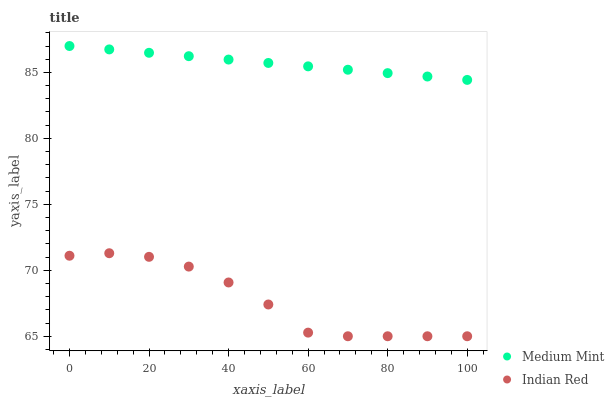Does Indian Red have the minimum area under the curve?
Answer yes or no. Yes. Does Medium Mint have the maximum area under the curve?
Answer yes or no. Yes. Does Indian Red have the maximum area under the curve?
Answer yes or no. No. Is Medium Mint the smoothest?
Answer yes or no. Yes. Is Indian Red the roughest?
Answer yes or no. Yes. Is Indian Red the smoothest?
Answer yes or no. No. Does Indian Red have the lowest value?
Answer yes or no. Yes. Does Medium Mint have the highest value?
Answer yes or no. Yes. Does Indian Red have the highest value?
Answer yes or no. No. Is Indian Red less than Medium Mint?
Answer yes or no. Yes. Is Medium Mint greater than Indian Red?
Answer yes or no. Yes. Does Indian Red intersect Medium Mint?
Answer yes or no. No. 